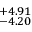<formula> <loc_0><loc_0><loc_500><loc_500>^ { + 4 . 9 1 } _ { - 4 . 2 0 }</formula> 